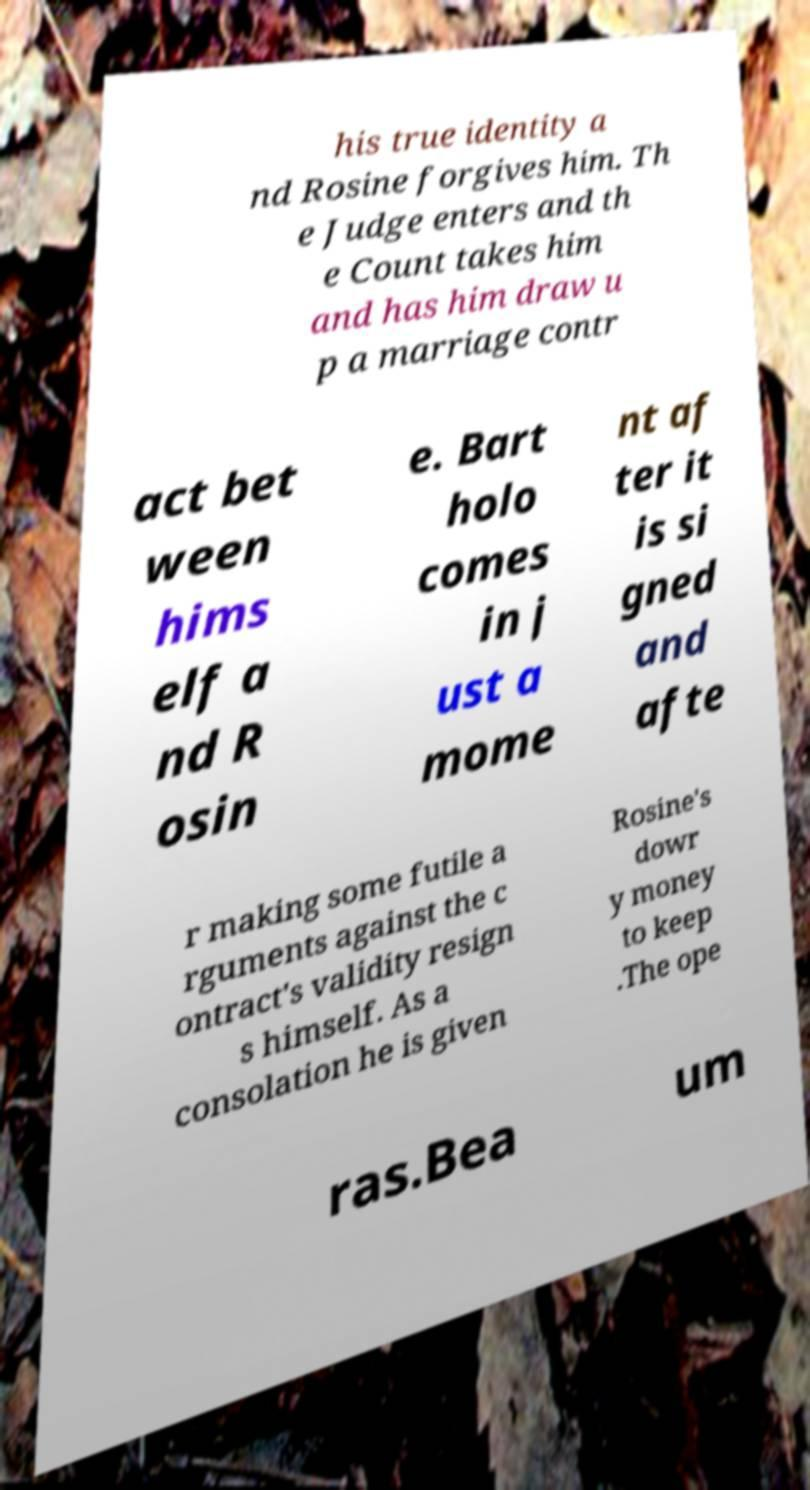Could you extract and type out the text from this image? his true identity a nd Rosine forgives him. Th e Judge enters and th e Count takes him and has him draw u p a marriage contr act bet ween hims elf a nd R osin e. Bart holo comes in j ust a mome nt af ter it is si gned and afte r making some futile a rguments against the c ontract's validity resign s himself. As a consolation he is given Rosine's dowr y money to keep .The ope ras.Bea um 